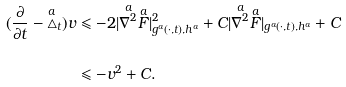<formula> <loc_0><loc_0><loc_500><loc_500>( \frac { \partial } { \partial t } - \overset { a } { \triangle } _ { t } ) v & \leqslant - 2 | \overset { a } { \nabla ^ { 2 } } \overset { a } { F } | ^ { 2 } _ { g ^ { a } ( \cdot , t ) , h ^ { a } } + C | \overset { a } { \nabla ^ { 2 } } \overset { a } { F } | _ { g ^ { a } ( \cdot , t ) , h ^ { a } } + C \\ & \leqslant - v ^ { 2 } + C .</formula> 